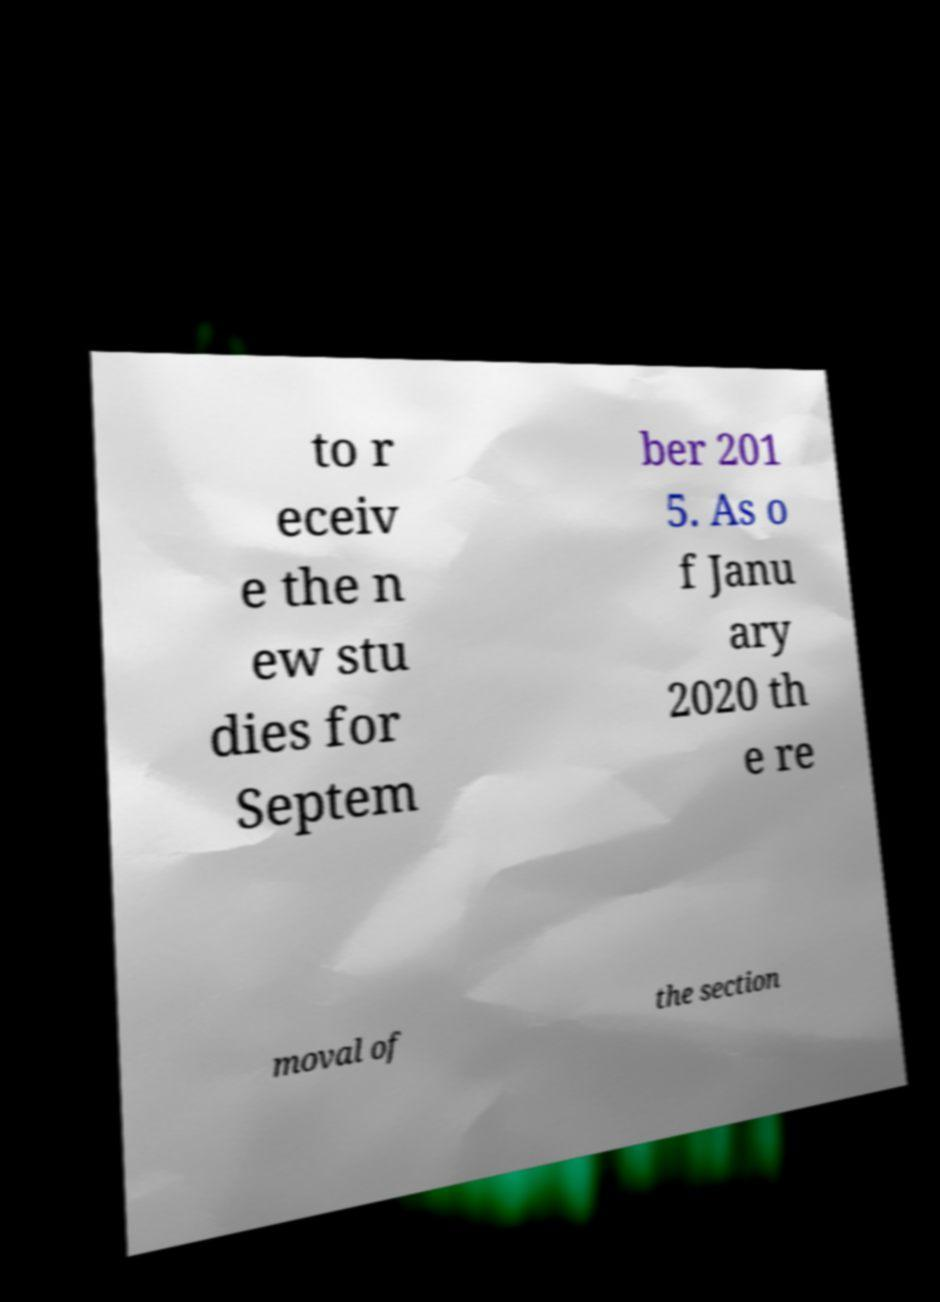What messages or text are displayed in this image? I need them in a readable, typed format. to r eceiv e the n ew stu dies for Septem ber 201 5. As o f Janu ary 2020 th e re moval of the section 